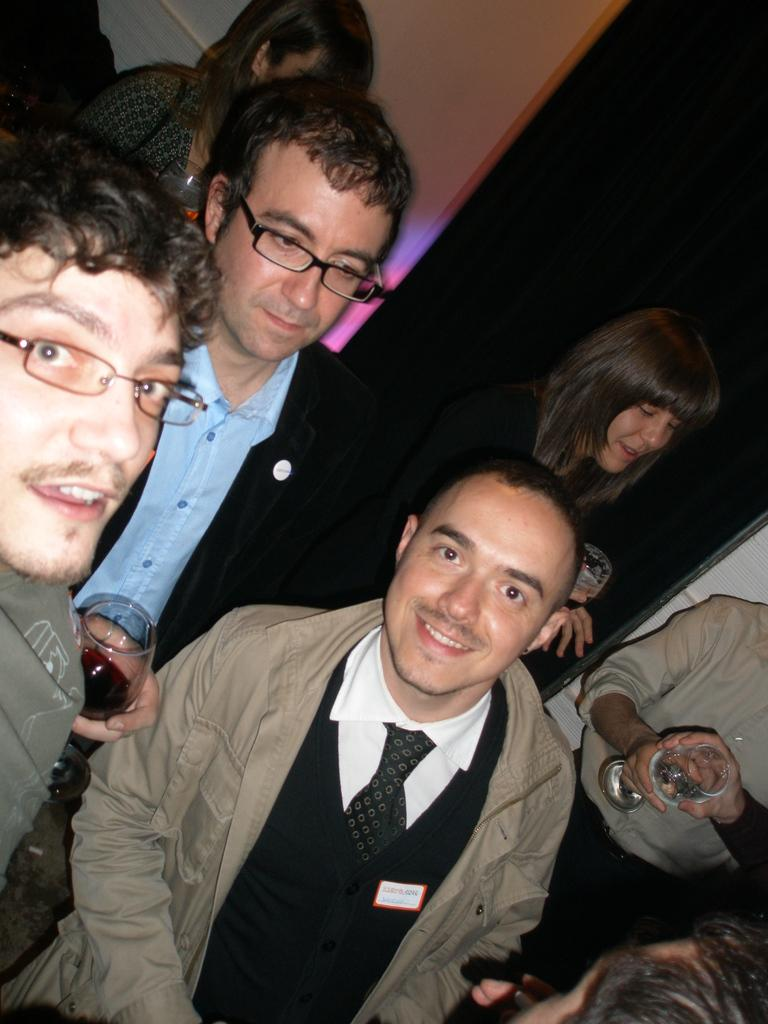How many people are in the image? There are people in the image, but the exact number is not specified. What can be observed about the clothing of the people in the image? The people in the image are wearing different color dresses. What are some people holding in the image? Some people are holding glasses in the image. What type of bomb can be seen in the image? There is no bomb present in the image. In which direction are the people in the image facing? The direction the people are facing is not specified in the image. 